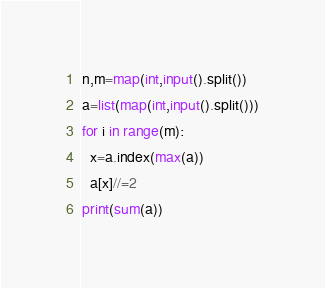Convert code to text. <code><loc_0><loc_0><loc_500><loc_500><_Python_>n,m=map(int,input().split())
a=list(map(int,input().split()))
for i in range(m):
  x=a.index(max(a))
  a[x]//=2
print(sum(a))</code> 